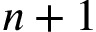<formula> <loc_0><loc_0><loc_500><loc_500>n + 1</formula> 